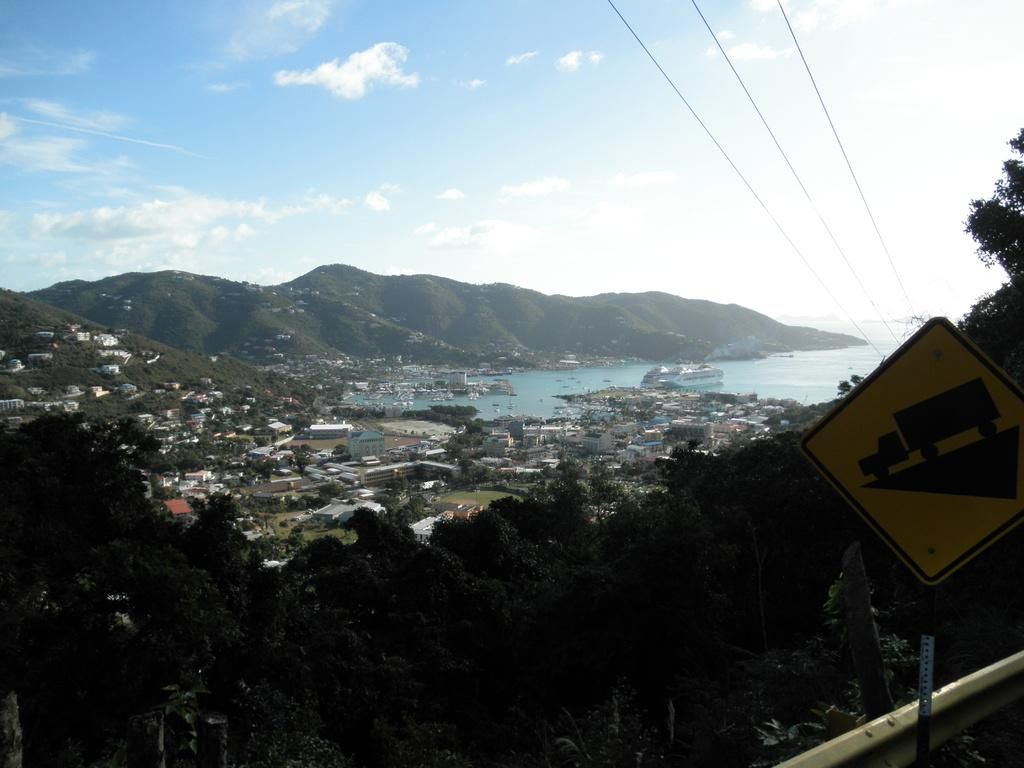What is the main object in the image? There is a sign board in the image. How is the sign board positioned? The sign board is attached to a pole. What can be seen in the background of the image? There are trees, buildings, water, and mountains in the background of the image. Where is the judge sitting in the image? There is no judge present in the image. What type of sack is being used to carry items in the image? There is no sack present in the image. 